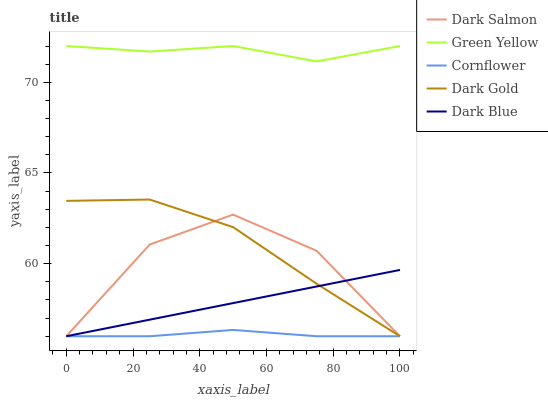Does Dark Blue have the minimum area under the curve?
Answer yes or no. No. Does Dark Blue have the maximum area under the curve?
Answer yes or no. No. Is Green Yellow the smoothest?
Answer yes or no. No. Is Green Yellow the roughest?
Answer yes or no. No. Does Green Yellow have the lowest value?
Answer yes or no. No. Does Dark Blue have the highest value?
Answer yes or no. No. Is Dark Gold less than Green Yellow?
Answer yes or no. Yes. Is Green Yellow greater than Dark Blue?
Answer yes or no. Yes. Does Dark Gold intersect Green Yellow?
Answer yes or no. No. 